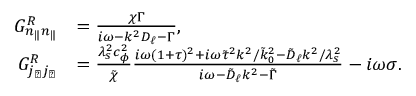Convert formula to latex. <formula><loc_0><loc_0><loc_500><loc_500>\begin{array} { r l } { G _ { n _ { \| } n _ { \| } } ^ { R } } & { = \frac { \chi \Gamma } { i \omega - k ^ { 2 } D _ { \ell } - \Gamma } , } \\ { G _ { j _ { \perp } j _ { \perp } } ^ { R } } & { = \frac { \lambda _ { s } ^ { 2 } c _ { \phi } ^ { 2 } } { \tilde { \chi } } \frac { i \omega ( 1 + \tau ) ^ { 2 } + i \omega \tilde { \tau } ^ { 2 } k ^ { 2 } / \tilde { k } _ { 0 } ^ { 2 } - \tilde { D } _ { \ell } k ^ { 2 } / \lambda _ { s } ^ { 2 } } { i \omega - \tilde { D } _ { \ell } k ^ { 2 } - \tilde { \Gamma } } - i \omega \sigma . } \end{array}</formula> 